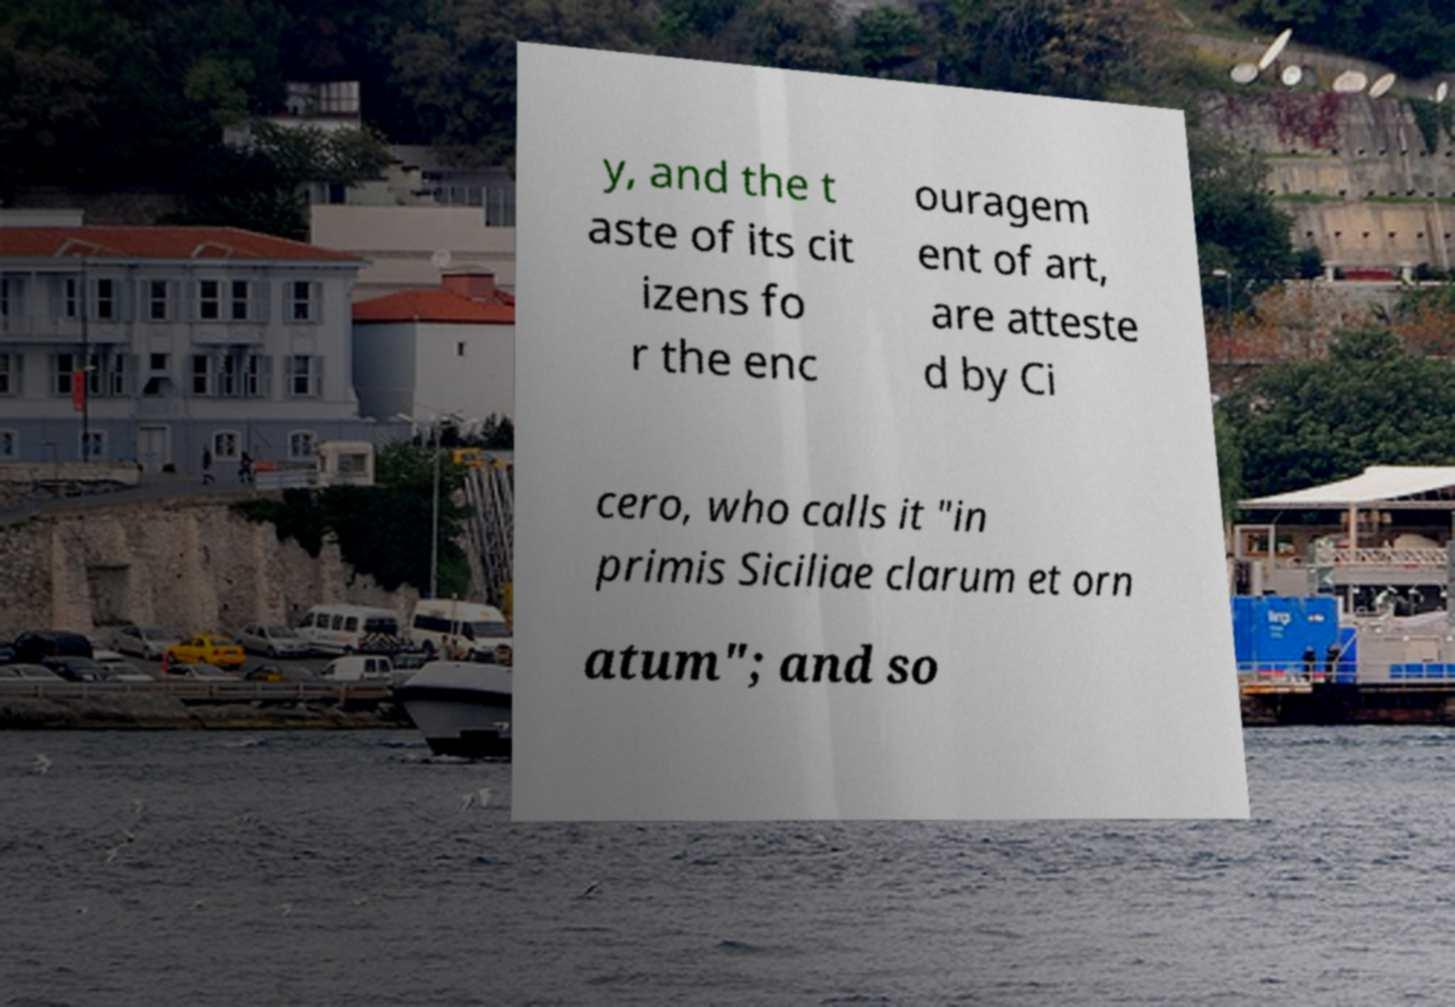Please read and relay the text visible in this image. What does it say? y, and the t aste of its cit izens fo r the enc ouragem ent of art, are atteste d by Ci cero, who calls it "in primis Siciliae clarum et orn atum"; and so 